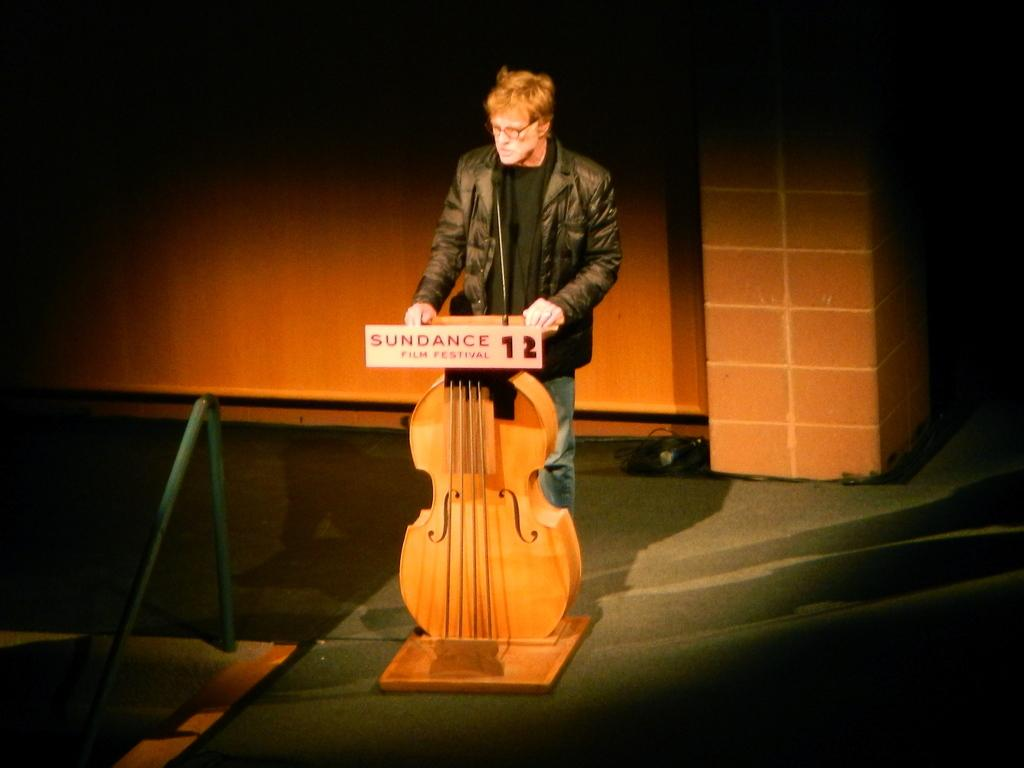Who is the main subject in the image? There is a man in the image. What is the man wearing? The man is wearing a black jacket. What object is in front of the man? There is a microphone in front of the man. What is the shape of the podium the man is standing by? The podium is violin-shaped. What can be seen in the background of the image? There is a wall in the background of the image. What type of pot is being used to store knowledge in the image? There is no pot or knowledge storage mentioned in the image; it features a man with a microphone and a violin-shaped podium. 